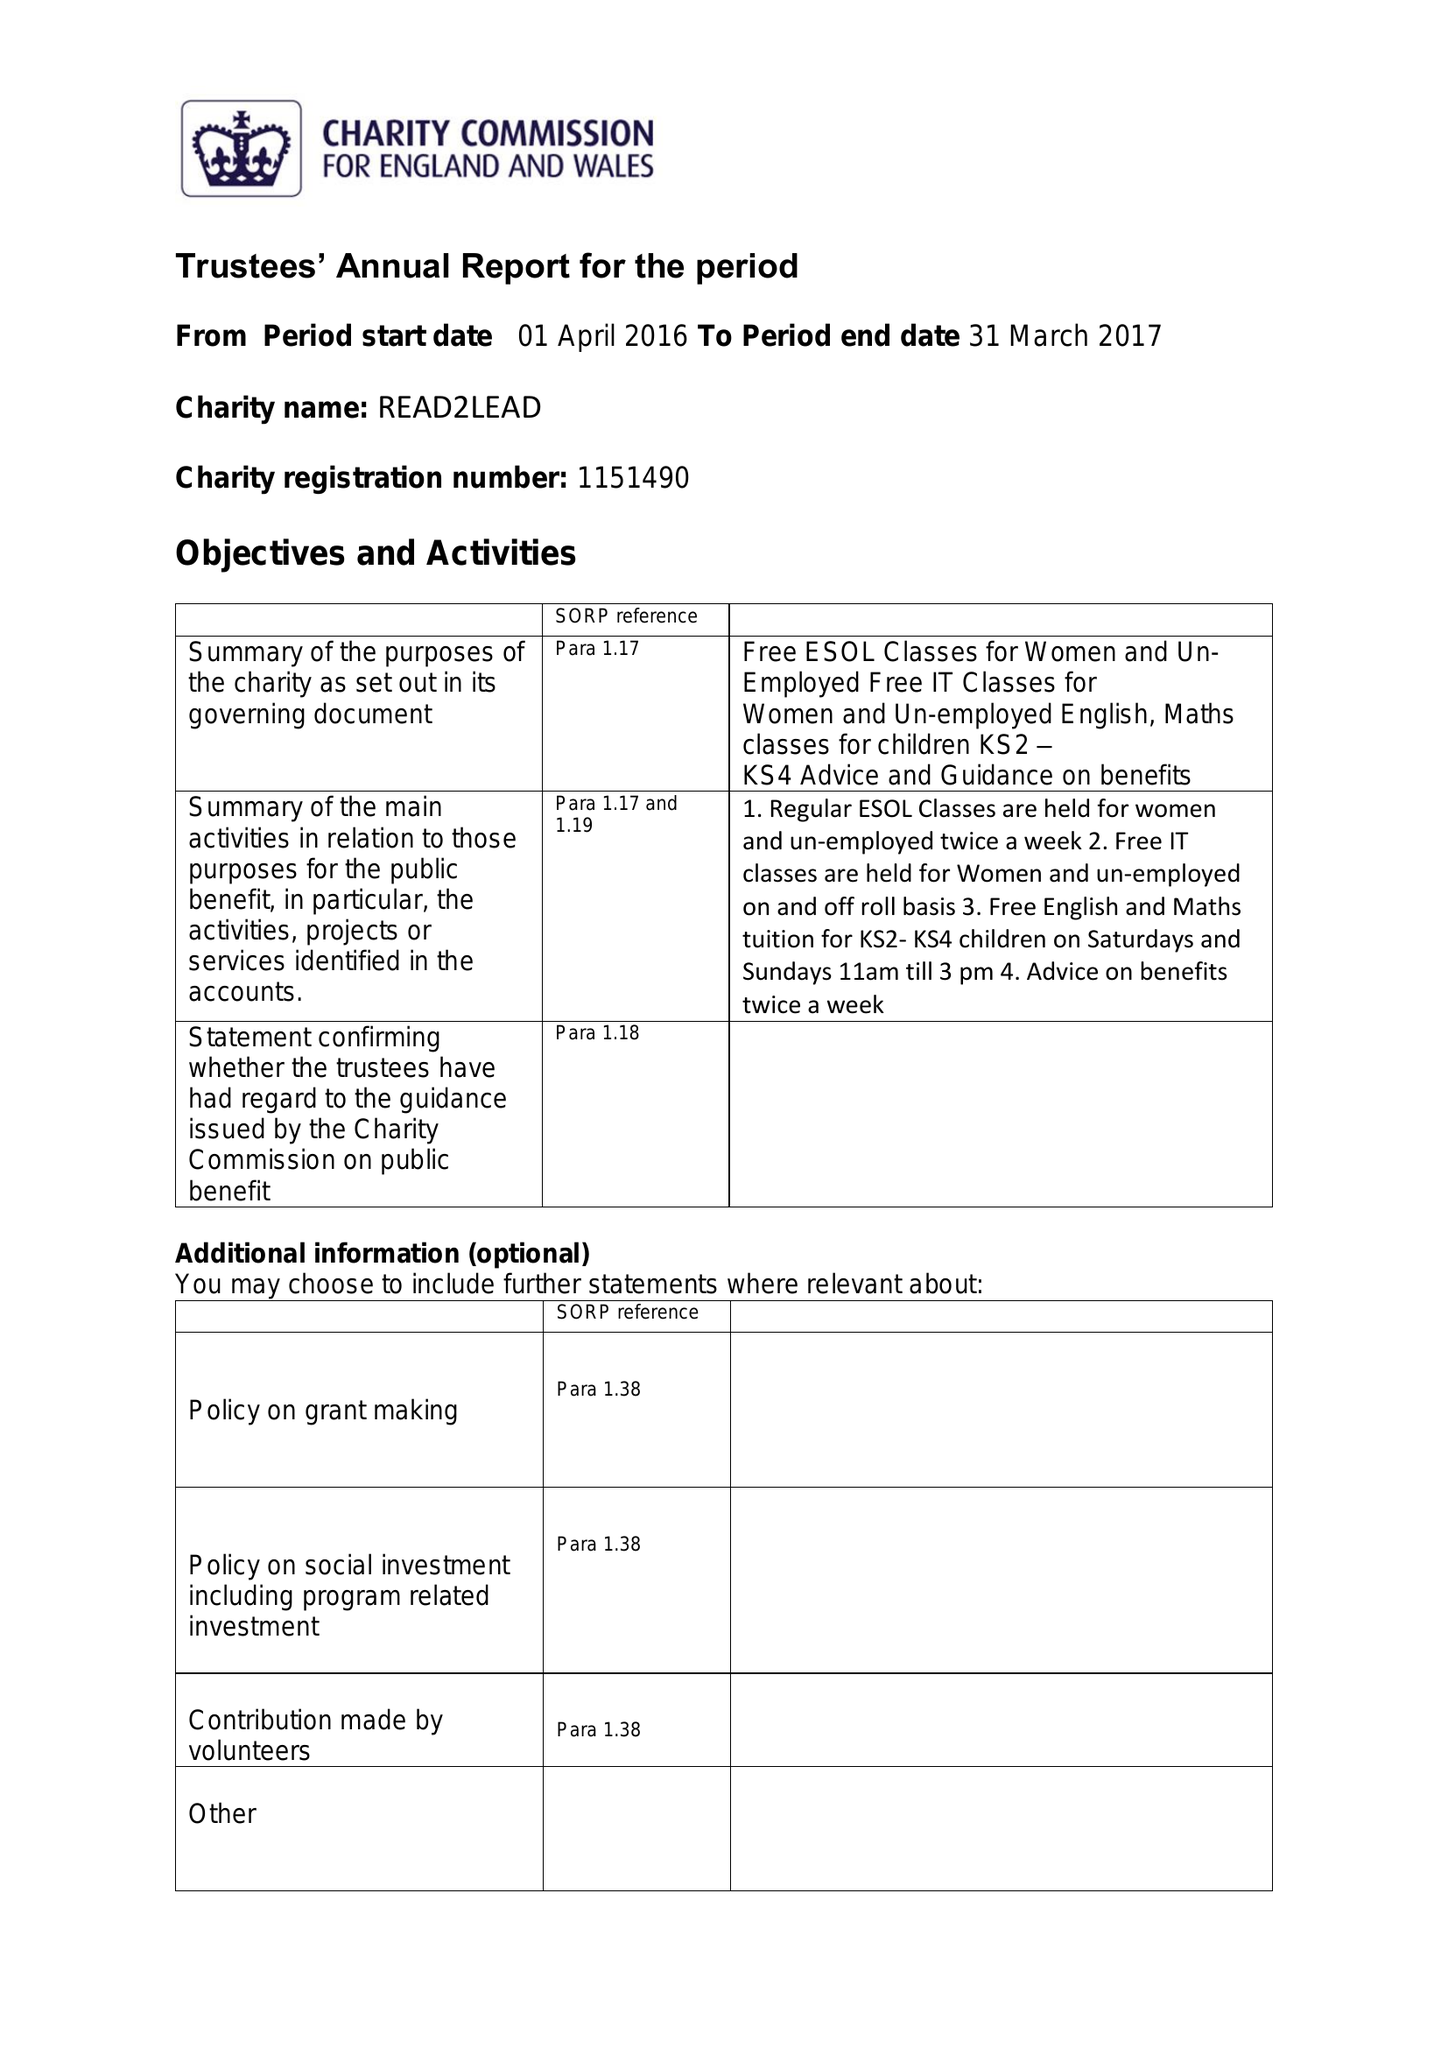What is the value for the report_date?
Answer the question using a single word or phrase. 2017-03-31 